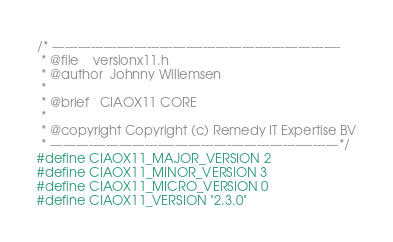Convert code to text. <code><loc_0><loc_0><loc_500><loc_500><_C_>/* -------------------------------------------------------------------
 * @file    versionx11.h
 * @author  Johnny Willemsen
 *
 * @brief   CIAOX11 CORE
 *
 * @copyright Copyright (c) Remedy IT Expertise BV
 * -------------------------------------------------------------------*/
#define CIAOX11_MAJOR_VERSION 2
#define CIAOX11_MINOR_VERSION 3
#define CIAOX11_MICRO_VERSION 0
#define CIAOX11_VERSION "2.3.0"
</code> 